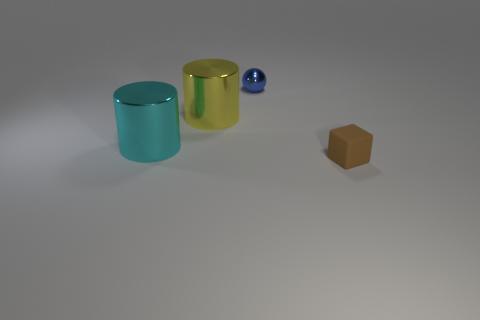Add 4 metallic cylinders. How many objects exist? 8 Subtract all yellow cylinders. How many cylinders are left? 1 Add 1 tiny shiny balls. How many tiny shiny balls are left? 2 Add 3 large cyan objects. How many large cyan objects exist? 4 Subtract 0 blue cubes. How many objects are left? 4 Subtract all blocks. How many objects are left? 3 Subtract all yellow cubes. Subtract all blue cylinders. How many cubes are left? 1 Subtract all gray cylinders. How many brown spheres are left? 0 Subtract all small green metallic cubes. Subtract all big cyan metal things. How many objects are left? 3 